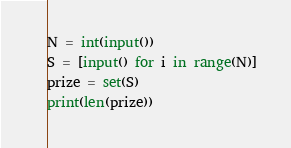<code> <loc_0><loc_0><loc_500><loc_500><_Python_>N = int(input())
S = [input() for i in range(N)]
prize = set(S)
print(len(prize))
</code> 